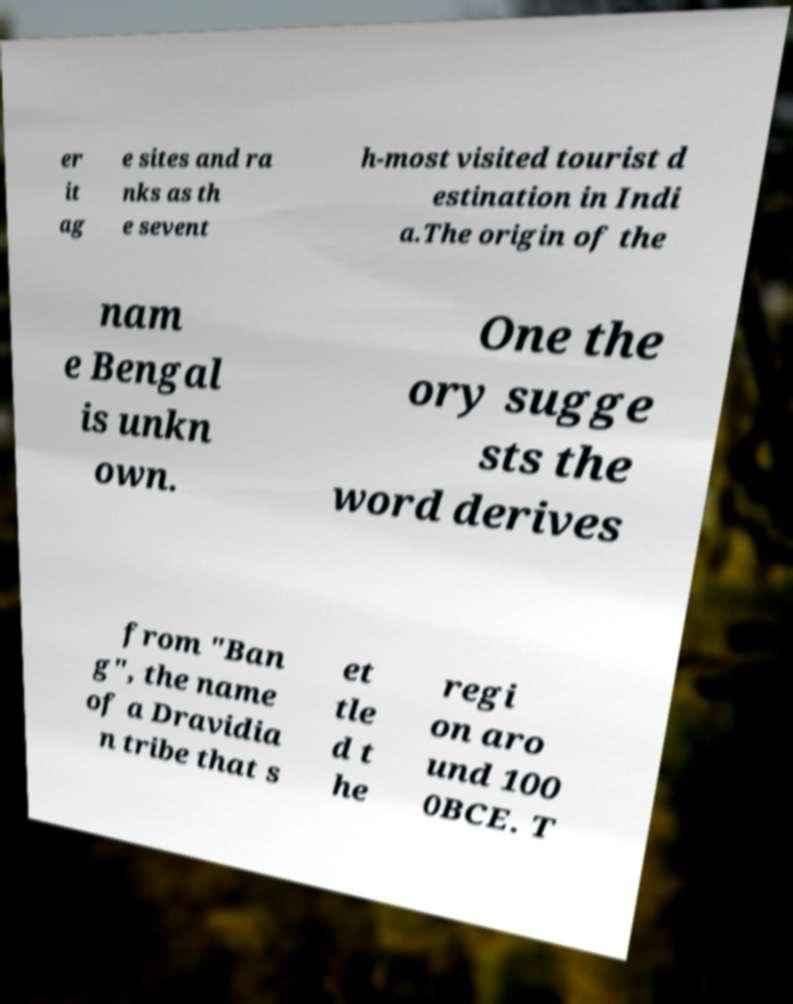There's text embedded in this image that I need extracted. Can you transcribe it verbatim? er it ag e sites and ra nks as th e sevent h-most visited tourist d estination in Indi a.The origin of the nam e Bengal is unkn own. One the ory sugge sts the word derives from "Ban g", the name of a Dravidia n tribe that s et tle d t he regi on aro und 100 0BCE. T 